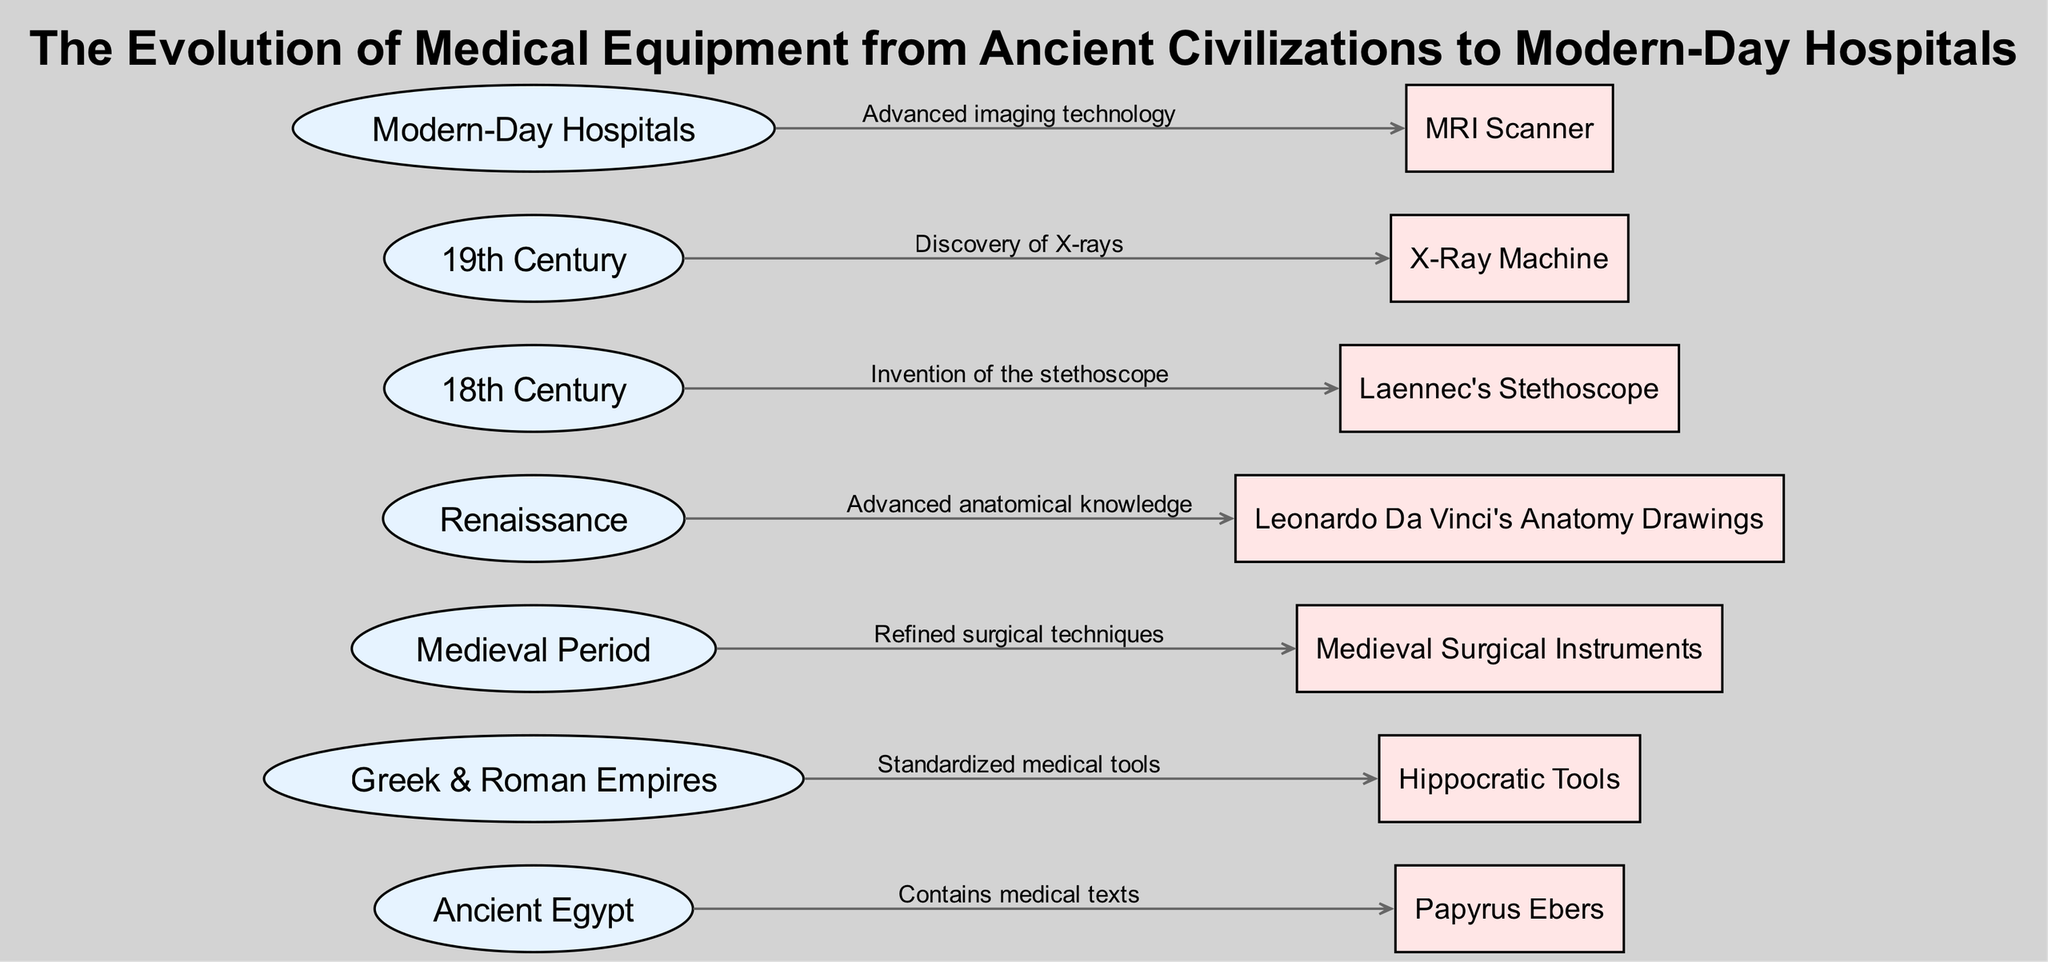What civilizations contributed to the development of medical equipment in the diagram? The diagram lists Ancient Egypt, Greek & Roman Empires, Medieval Period, Renaissance, 18th Century, 19th Century, and Modern-Day Hospitals as civilizations or periods contributing to medical equipment evolution.
Answer: Ancient Egypt, Greek & Roman Empires, Medieval Period, Renaissance, 18th Century, 19th Century, Modern-Day Hospitals How many types of medical equipment are illustrated in the diagram? The diagram includes seven distinct pieces of medical equipment: Papyrus Ebers, Hippocratic Tools, Medieval Surgical Instruments, Leonardo Da Vinci's Anatomy Drawings, Laennec's Stethoscope, X-Ray Machine, and MRI Scanner.
Answer: Seven What medical text originated in Ancient Egypt? The diagram indicates that the Papyrus Ebers contains medical texts that were significant in Ancient Egypt's contributions to medicine.
Answer: Papyrus Ebers Which period is associated with the invention of the stethoscope? The diagram arrow connects the 18th Century to Laennec's Stethoscope, indicating that the stethoscope was invented during this period.
Answer: 18th Century What advancement did Renaissance contribute to medical knowledge? The diagram illustrates that the Renaissance period led to advanced anatomical knowledge, exemplified by Leonardo Da Vinci's Anatomy Drawings.
Answer: Advanced anatomical knowledge Which medical equipment was discovered in the 19th Century? The X-Ray Machine is indicated in the diagram as the equipment related to discoveries made during the 19th Century.
Answer: X-Ray Machine What did medieval surgical instruments improve upon? The diagram highlights that Medieval Surgical Instruments were associated with refined surgical techniques developed during the Medieval Period.
Answer: Refined surgical techniques What advanced technology is used in modern-day hospitals according to the diagram? The diagram points to the MRI Scanner as an example of advanced imaging technology utilized in modern-day hospitals.
Answer: MRI Scanner How are the Hippocratic Tools categorized in the diagram? The diagram categorizes Hippocratic Tools as medical equipment developed during the Greek & Roman Empires, indicated by the connecting arrow.
Answer: Box 